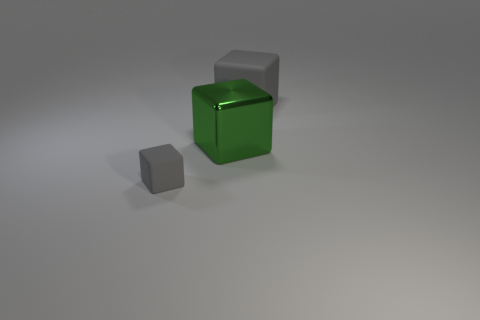Do the tiny rubber cube on the left side of the green object and the object behind the green metallic block have the same color?
Your answer should be very brief. Yes. The object that is on the right side of the tiny gray rubber thing and left of the large gray matte cube has what shape?
Provide a succinct answer. Cube. The other object that is the same size as the green object is what color?
Your answer should be compact. Gray. Are there any other big blocks of the same color as the metallic block?
Your response must be concise. No. Does the gray rubber block on the right side of the big green metal block have the same size as the gray rubber object to the left of the large gray object?
Make the answer very short. No. There is a thing that is on the right side of the small object and in front of the large gray block; what material is it?
Your answer should be very brief. Metal. There is a thing that is the same color as the small block; what size is it?
Offer a terse response. Large. How many other things are the same size as the green object?
Your response must be concise. 1. What is the material of the big block that is on the left side of the large gray thing?
Make the answer very short. Metal. Is the shape of the large gray matte object the same as the big green shiny thing?
Provide a succinct answer. Yes. 